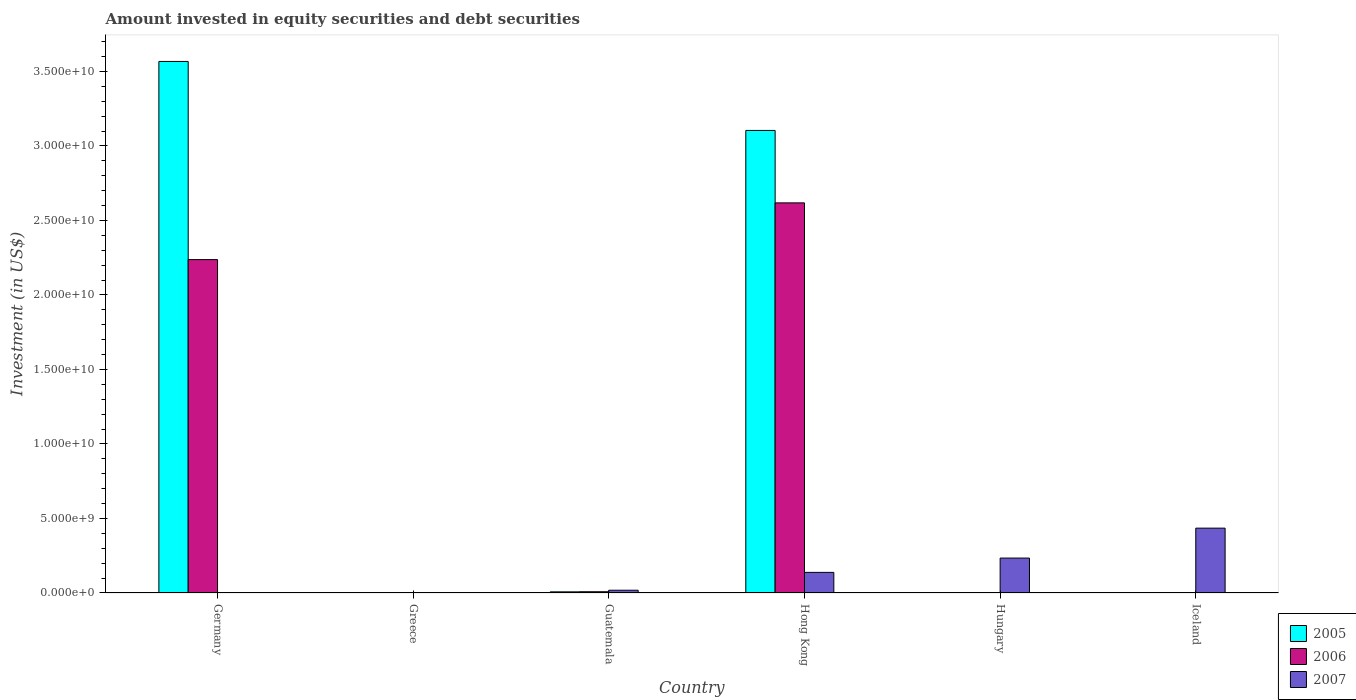How many different coloured bars are there?
Offer a very short reply. 3. How many bars are there on the 1st tick from the right?
Give a very brief answer. 1. What is the label of the 5th group of bars from the left?
Make the answer very short. Hungary. What is the amount invested in equity securities and debt securities in 2006 in Guatemala?
Give a very brief answer. 8.34e+07. Across all countries, what is the maximum amount invested in equity securities and debt securities in 2005?
Keep it short and to the point. 3.57e+1. In which country was the amount invested in equity securities and debt securities in 2007 maximum?
Your answer should be compact. Iceland. What is the total amount invested in equity securities and debt securities in 2006 in the graph?
Ensure brevity in your answer.  4.86e+1. What is the difference between the amount invested in equity securities and debt securities in 2007 in Guatemala and that in Hungary?
Your answer should be very brief. -2.16e+09. What is the difference between the amount invested in equity securities and debt securities in 2007 in Hong Kong and the amount invested in equity securities and debt securities in 2005 in Greece?
Ensure brevity in your answer.  1.38e+09. What is the average amount invested in equity securities and debt securities in 2006 per country?
Keep it short and to the point. 8.11e+09. What is the difference between the amount invested in equity securities and debt securities of/in 2005 and amount invested in equity securities and debt securities of/in 2007 in Hong Kong?
Offer a very short reply. 2.97e+1. What is the ratio of the amount invested in equity securities and debt securities in 2007 in Hong Kong to that in Iceland?
Your response must be concise. 0.32. Is the amount invested in equity securities and debt securities in 2007 in Guatemala less than that in Hong Kong?
Your response must be concise. Yes. What is the difference between the highest and the second highest amount invested in equity securities and debt securities in 2006?
Offer a terse response. -2.61e+1. What is the difference between the highest and the lowest amount invested in equity securities and debt securities in 2007?
Offer a terse response. 4.35e+09. In how many countries, is the amount invested in equity securities and debt securities in 2005 greater than the average amount invested in equity securities and debt securities in 2005 taken over all countries?
Keep it short and to the point. 2. Is the sum of the amount invested in equity securities and debt securities in 2007 in Hong Kong and Hungary greater than the maximum amount invested in equity securities and debt securities in 2005 across all countries?
Your answer should be very brief. No. Is it the case that in every country, the sum of the amount invested in equity securities and debt securities in 2006 and amount invested in equity securities and debt securities in 2005 is greater than the amount invested in equity securities and debt securities in 2007?
Your answer should be compact. No. How many bars are there?
Provide a short and direct response. 10. Are all the bars in the graph horizontal?
Ensure brevity in your answer.  No. How many countries are there in the graph?
Provide a short and direct response. 6. What is the title of the graph?
Make the answer very short. Amount invested in equity securities and debt securities. Does "1998" appear as one of the legend labels in the graph?
Offer a terse response. No. What is the label or title of the Y-axis?
Ensure brevity in your answer.  Investment (in US$). What is the Investment (in US$) in 2005 in Germany?
Ensure brevity in your answer.  3.57e+1. What is the Investment (in US$) of 2006 in Germany?
Your response must be concise. 2.24e+1. What is the Investment (in US$) in 2005 in Greece?
Ensure brevity in your answer.  0. What is the Investment (in US$) of 2006 in Greece?
Your answer should be compact. 0. What is the Investment (in US$) of 2007 in Greece?
Ensure brevity in your answer.  0. What is the Investment (in US$) of 2005 in Guatemala?
Offer a very short reply. 7.68e+07. What is the Investment (in US$) of 2006 in Guatemala?
Provide a succinct answer. 8.34e+07. What is the Investment (in US$) of 2007 in Guatemala?
Your response must be concise. 1.85e+08. What is the Investment (in US$) in 2005 in Hong Kong?
Give a very brief answer. 3.10e+1. What is the Investment (in US$) in 2006 in Hong Kong?
Your response must be concise. 2.62e+1. What is the Investment (in US$) in 2007 in Hong Kong?
Your answer should be very brief. 1.38e+09. What is the Investment (in US$) in 2005 in Hungary?
Your response must be concise. 0. What is the Investment (in US$) of 2007 in Hungary?
Your answer should be very brief. 2.34e+09. What is the Investment (in US$) of 2005 in Iceland?
Provide a succinct answer. 0. What is the Investment (in US$) in 2007 in Iceland?
Offer a terse response. 4.35e+09. Across all countries, what is the maximum Investment (in US$) of 2005?
Offer a terse response. 3.57e+1. Across all countries, what is the maximum Investment (in US$) in 2006?
Provide a succinct answer. 2.62e+1. Across all countries, what is the maximum Investment (in US$) in 2007?
Offer a very short reply. 4.35e+09. Across all countries, what is the minimum Investment (in US$) of 2007?
Your answer should be compact. 0. What is the total Investment (in US$) in 2005 in the graph?
Your response must be concise. 6.68e+1. What is the total Investment (in US$) of 2006 in the graph?
Your answer should be very brief. 4.86e+1. What is the total Investment (in US$) of 2007 in the graph?
Provide a succinct answer. 8.26e+09. What is the difference between the Investment (in US$) in 2005 in Germany and that in Guatemala?
Offer a very short reply. 3.56e+1. What is the difference between the Investment (in US$) in 2006 in Germany and that in Guatemala?
Give a very brief answer. 2.23e+1. What is the difference between the Investment (in US$) in 2005 in Germany and that in Hong Kong?
Ensure brevity in your answer.  4.63e+09. What is the difference between the Investment (in US$) of 2006 in Germany and that in Hong Kong?
Your answer should be compact. -3.81e+09. What is the difference between the Investment (in US$) of 2005 in Guatemala and that in Hong Kong?
Your response must be concise. -3.10e+1. What is the difference between the Investment (in US$) in 2006 in Guatemala and that in Hong Kong?
Keep it short and to the point. -2.61e+1. What is the difference between the Investment (in US$) of 2007 in Guatemala and that in Hong Kong?
Make the answer very short. -1.20e+09. What is the difference between the Investment (in US$) of 2007 in Guatemala and that in Hungary?
Ensure brevity in your answer.  -2.16e+09. What is the difference between the Investment (in US$) of 2007 in Guatemala and that in Iceland?
Keep it short and to the point. -4.17e+09. What is the difference between the Investment (in US$) in 2007 in Hong Kong and that in Hungary?
Give a very brief answer. -9.60e+08. What is the difference between the Investment (in US$) in 2007 in Hong Kong and that in Iceland?
Give a very brief answer. -2.97e+09. What is the difference between the Investment (in US$) of 2007 in Hungary and that in Iceland?
Provide a succinct answer. -2.01e+09. What is the difference between the Investment (in US$) of 2005 in Germany and the Investment (in US$) of 2006 in Guatemala?
Provide a succinct answer. 3.56e+1. What is the difference between the Investment (in US$) of 2005 in Germany and the Investment (in US$) of 2007 in Guatemala?
Ensure brevity in your answer.  3.55e+1. What is the difference between the Investment (in US$) of 2006 in Germany and the Investment (in US$) of 2007 in Guatemala?
Your answer should be compact. 2.22e+1. What is the difference between the Investment (in US$) in 2005 in Germany and the Investment (in US$) in 2006 in Hong Kong?
Make the answer very short. 9.49e+09. What is the difference between the Investment (in US$) in 2005 in Germany and the Investment (in US$) in 2007 in Hong Kong?
Provide a short and direct response. 3.43e+1. What is the difference between the Investment (in US$) of 2006 in Germany and the Investment (in US$) of 2007 in Hong Kong?
Provide a succinct answer. 2.10e+1. What is the difference between the Investment (in US$) of 2005 in Germany and the Investment (in US$) of 2007 in Hungary?
Give a very brief answer. 3.33e+1. What is the difference between the Investment (in US$) of 2006 in Germany and the Investment (in US$) of 2007 in Hungary?
Ensure brevity in your answer.  2.00e+1. What is the difference between the Investment (in US$) of 2005 in Germany and the Investment (in US$) of 2007 in Iceland?
Offer a very short reply. 3.13e+1. What is the difference between the Investment (in US$) in 2006 in Germany and the Investment (in US$) in 2007 in Iceland?
Make the answer very short. 1.80e+1. What is the difference between the Investment (in US$) of 2005 in Guatemala and the Investment (in US$) of 2006 in Hong Kong?
Your response must be concise. -2.61e+1. What is the difference between the Investment (in US$) of 2005 in Guatemala and the Investment (in US$) of 2007 in Hong Kong?
Your answer should be compact. -1.31e+09. What is the difference between the Investment (in US$) of 2006 in Guatemala and the Investment (in US$) of 2007 in Hong Kong?
Offer a very short reply. -1.30e+09. What is the difference between the Investment (in US$) in 2005 in Guatemala and the Investment (in US$) in 2007 in Hungary?
Make the answer very short. -2.27e+09. What is the difference between the Investment (in US$) of 2006 in Guatemala and the Investment (in US$) of 2007 in Hungary?
Your response must be concise. -2.26e+09. What is the difference between the Investment (in US$) of 2005 in Guatemala and the Investment (in US$) of 2007 in Iceland?
Your response must be concise. -4.27e+09. What is the difference between the Investment (in US$) in 2006 in Guatemala and the Investment (in US$) in 2007 in Iceland?
Provide a succinct answer. -4.27e+09. What is the difference between the Investment (in US$) in 2005 in Hong Kong and the Investment (in US$) in 2007 in Hungary?
Keep it short and to the point. 2.87e+1. What is the difference between the Investment (in US$) in 2006 in Hong Kong and the Investment (in US$) in 2007 in Hungary?
Offer a very short reply. 2.38e+1. What is the difference between the Investment (in US$) of 2005 in Hong Kong and the Investment (in US$) of 2007 in Iceland?
Provide a succinct answer. 2.67e+1. What is the difference between the Investment (in US$) in 2006 in Hong Kong and the Investment (in US$) in 2007 in Iceland?
Offer a terse response. 2.18e+1. What is the average Investment (in US$) in 2005 per country?
Your answer should be very brief. 1.11e+1. What is the average Investment (in US$) in 2006 per country?
Your answer should be compact. 8.11e+09. What is the average Investment (in US$) in 2007 per country?
Keep it short and to the point. 1.38e+09. What is the difference between the Investment (in US$) in 2005 and Investment (in US$) in 2006 in Germany?
Offer a terse response. 1.33e+1. What is the difference between the Investment (in US$) of 2005 and Investment (in US$) of 2006 in Guatemala?
Give a very brief answer. -6.60e+06. What is the difference between the Investment (in US$) in 2005 and Investment (in US$) in 2007 in Guatemala?
Make the answer very short. -1.08e+08. What is the difference between the Investment (in US$) in 2006 and Investment (in US$) in 2007 in Guatemala?
Offer a terse response. -1.02e+08. What is the difference between the Investment (in US$) of 2005 and Investment (in US$) of 2006 in Hong Kong?
Provide a short and direct response. 4.86e+09. What is the difference between the Investment (in US$) of 2005 and Investment (in US$) of 2007 in Hong Kong?
Offer a terse response. 2.97e+1. What is the difference between the Investment (in US$) in 2006 and Investment (in US$) in 2007 in Hong Kong?
Ensure brevity in your answer.  2.48e+1. What is the ratio of the Investment (in US$) in 2005 in Germany to that in Guatemala?
Give a very brief answer. 464.44. What is the ratio of the Investment (in US$) in 2006 in Germany to that in Guatemala?
Make the answer very short. 268.25. What is the ratio of the Investment (in US$) in 2005 in Germany to that in Hong Kong?
Provide a short and direct response. 1.15. What is the ratio of the Investment (in US$) in 2006 in Germany to that in Hong Kong?
Keep it short and to the point. 0.85. What is the ratio of the Investment (in US$) of 2005 in Guatemala to that in Hong Kong?
Make the answer very short. 0. What is the ratio of the Investment (in US$) of 2006 in Guatemala to that in Hong Kong?
Keep it short and to the point. 0. What is the ratio of the Investment (in US$) in 2007 in Guatemala to that in Hong Kong?
Offer a terse response. 0.13. What is the ratio of the Investment (in US$) in 2007 in Guatemala to that in Hungary?
Offer a terse response. 0.08. What is the ratio of the Investment (in US$) of 2007 in Guatemala to that in Iceland?
Keep it short and to the point. 0.04. What is the ratio of the Investment (in US$) in 2007 in Hong Kong to that in Hungary?
Provide a short and direct response. 0.59. What is the ratio of the Investment (in US$) in 2007 in Hong Kong to that in Iceland?
Your response must be concise. 0.32. What is the ratio of the Investment (in US$) of 2007 in Hungary to that in Iceland?
Offer a terse response. 0.54. What is the difference between the highest and the second highest Investment (in US$) of 2005?
Give a very brief answer. 4.63e+09. What is the difference between the highest and the second highest Investment (in US$) of 2006?
Your answer should be compact. 3.81e+09. What is the difference between the highest and the second highest Investment (in US$) of 2007?
Offer a very short reply. 2.01e+09. What is the difference between the highest and the lowest Investment (in US$) in 2005?
Your answer should be compact. 3.57e+1. What is the difference between the highest and the lowest Investment (in US$) in 2006?
Provide a short and direct response. 2.62e+1. What is the difference between the highest and the lowest Investment (in US$) in 2007?
Your answer should be compact. 4.35e+09. 